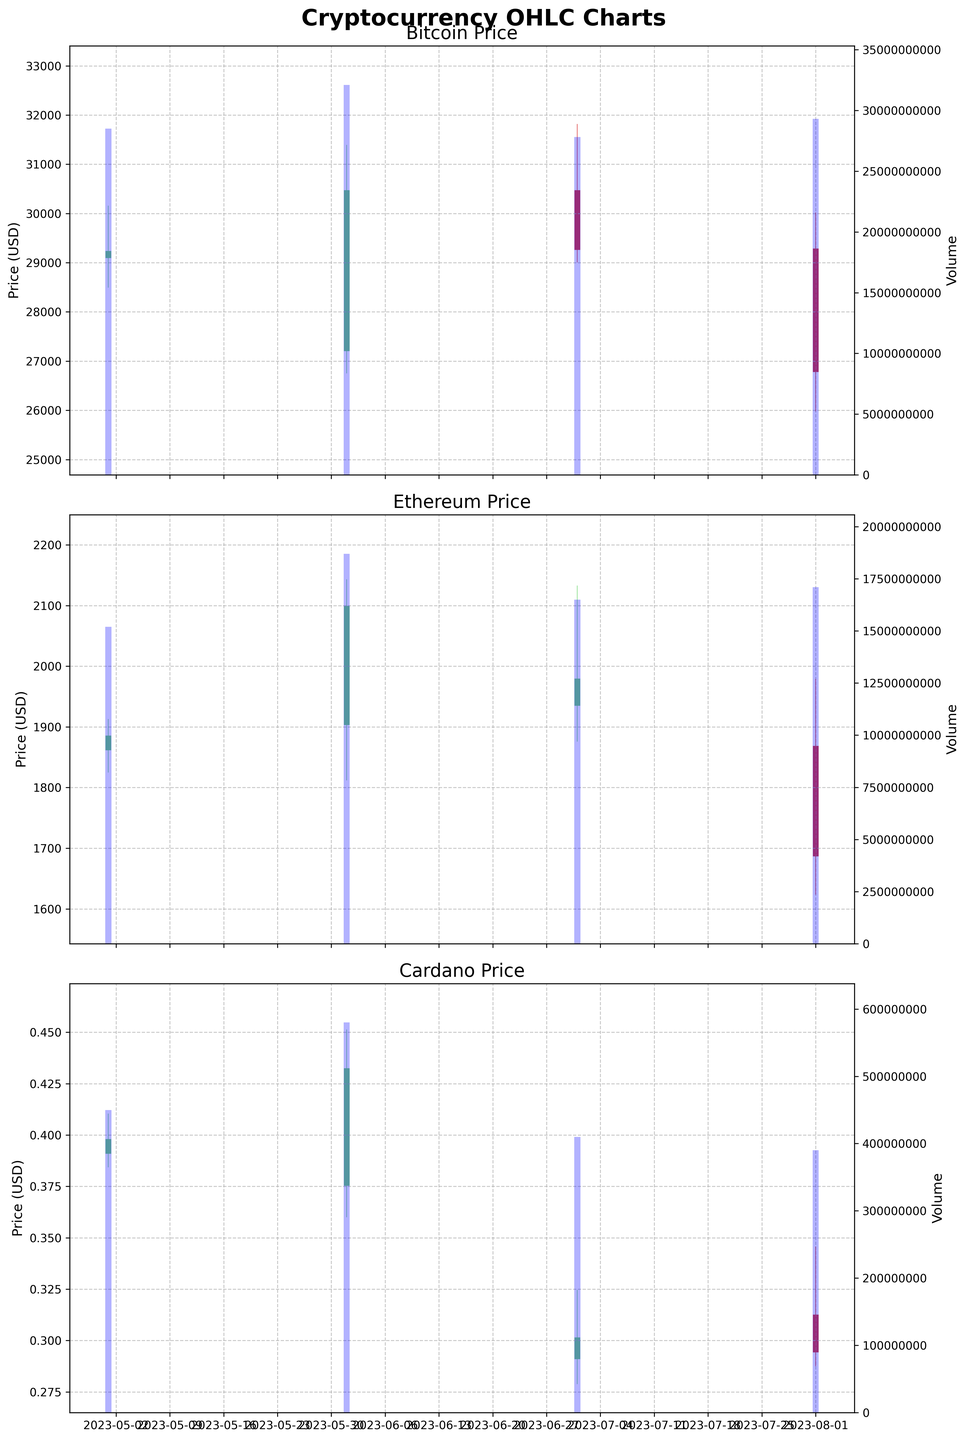Which cryptocurrency had the highest trading volume in June 2023? To determine the cryptocurrency with the highest trading volume in June 2023, look at the volume bars for each currency in that month. Bitcoin's volume is 32.1 billion, Ethereum's volume is 18.7 billion, and Cardano's volume is 580 million. Bitcoin has the highest volume.
Answer: Bitcoin What's the overall trend for Bitcoin prices from May to August 2023? Observe the OHLC candlesticks for Bitcoin over the given months. The OHLC shows that the price started high in May, dipped in June, slightly recovered in July, but then fell again in August. This indicates a fluctuating but generally declining trend.
Answer: Declining Which month had the highest closing price for Ethereum? Look at the closing prices for Ethereum in each month. In May 2023, the closing price is 1884.92. In June, it's 2098.45, in July, it's 1978.56, and in August, it's 1687.34. The highest closing price is in June 2023.
Answer: June 2023 Compare the price volatility of Cardano between July and August 2023. Price volatility can be observed by checking the range between the high and low prices in each month. In July, the range is between 0.3245 and 0.2789, while in August, it's between 0.3456 and 0.2876. The range is larger in August, indicating higher volatility.
Answer: August 2023 Did any cryptocurrency have a consistently increasing volume from May to August 2023? Check the volume bar heights for each cryptocurrency month by month. Bitcoin: 28.5B, 32.1B, 27.8B, 29.3B. Ethereum: 15.2B, 18.7B, 16.5B, 17.1B. Cardano: 450M, 580M, 410M, 390M. None of the cryptocurrencies show a consistent increase.
Answer: No What was the maximum price of Bitcoin in June 2023? To find the maximum price of Bitcoin in June 2023, look at the highest point of the OHLC candlestick for that month. The high value is 31389.99.
Answer: 31389.99 How did the closing prices of Ethereum in August 2023 compare to its opening prices that month? For the comparison, look at the opening and closing prices of Ethereum in August 2023. The opening price is 1867.89, and the closing price is 1687.34. The closing price is lower than the opening price.
Answer: Lower Which month showed the largest difference between the high and low prices for Bitcoin? Check the high and low values of Bitcoin for each month and calculate the difference. May: 30154.78 - 28500.11 = 1654.67, June: 31389.99 - 26755.12 = 4634.87, July: 31814.56 - 29012.78 = 2801.78, August: 30012.78 - 25987.23 = 4025.55. June has the largest difference.
Answer: June 2023 Did the trading volume of Cardano show any clear upward or downward trend over the months? Review the volume bars for Cardano across the months: May (450M), June (580M), July (410M), August (390M). The volume decreases from June to August, indicating a downward trend.
Answer: Downward trend 